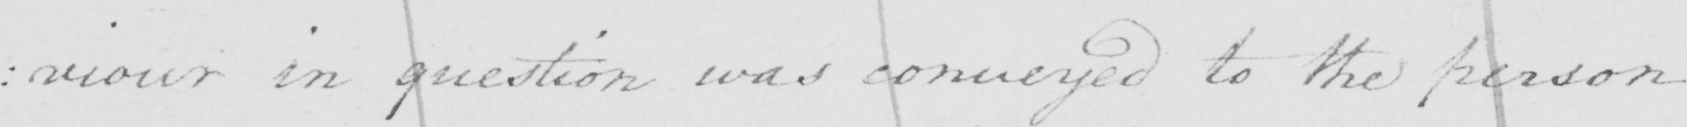What does this handwritten line say? : iour in question was conveyed to the person 